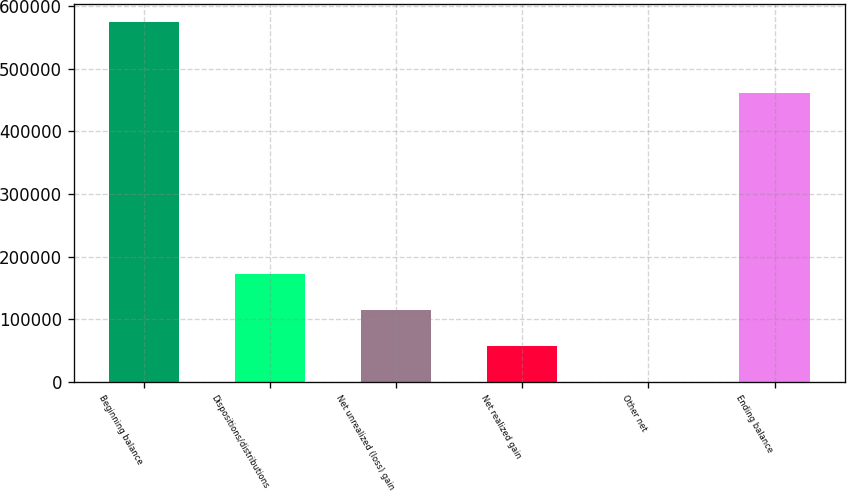Convert chart to OTSL. <chart><loc_0><loc_0><loc_500><loc_500><bar_chart><fcel>Beginning balance<fcel>Dispositions/distributions<fcel>Net unrealized (loss) gain<fcel>Net realized gain<fcel>Other net<fcel>Ending balance<nl><fcel>574761<fcel>172488<fcel>115021<fcel>57553.5<fcel>86<fcel>462132<nl></chart> 